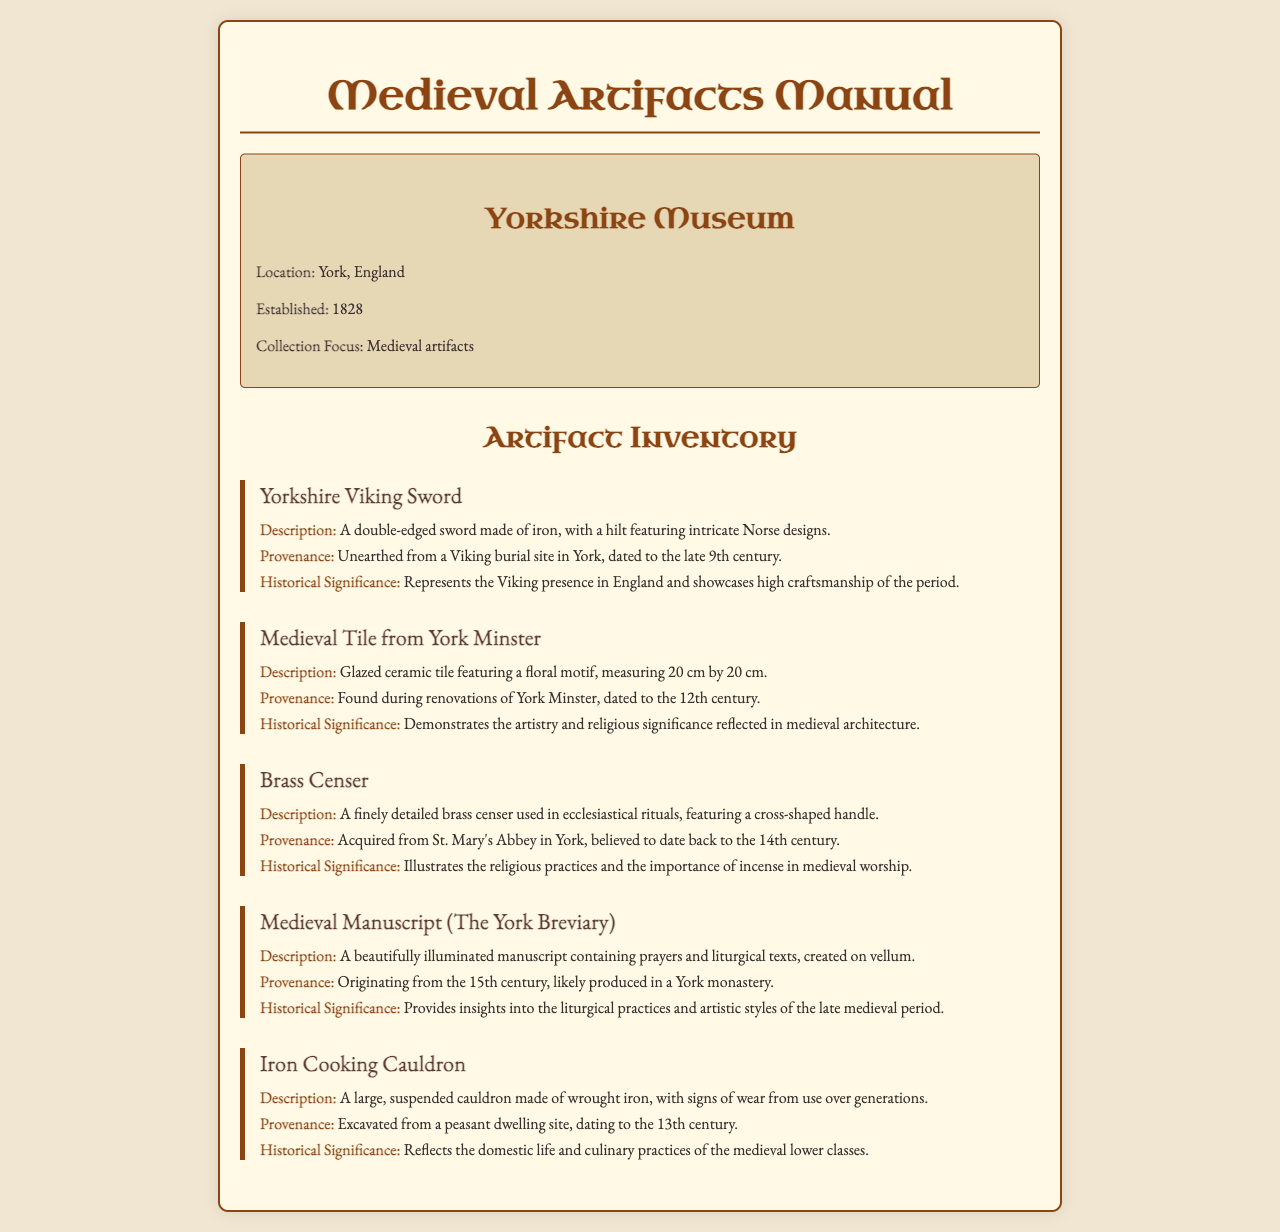What is the title of the manual? The title of the manual is stated at the beginning of the document.
Answer: Medieval Artifacts Manual Where is the Yorkshire Museum located? The location of the museum is mentioned in the museum information section.
Answer: York, England What year was the Yorkshire Museum established? The establishment year of the museum is provided in the museum information.
Answer: 1828 What century does the Yorkshire Viking Sword date back to? The dating of the Yorkshire Viking Sword is specified in its provenance.
Answer: Late 9th century Which artifact is associated with St. Mary's Abbey? This information is found in the provenance of one of the artifacts.
Answer: Brass Censer What does the Medieval Manuscript contain? The contents of the manuscript are described in its description section.
Answer: Prayers and liturgical texts What historical significance does the Iron Cooking Cauldron represent? The significance of the Iron Cooking Cauldron is explained in its historical significance section.
Answer: Domestic life and culinary practices How many artifacts are listed in the inventory? The number of distinct artifacts mentioned can be counted in the document.
Answer: Five 